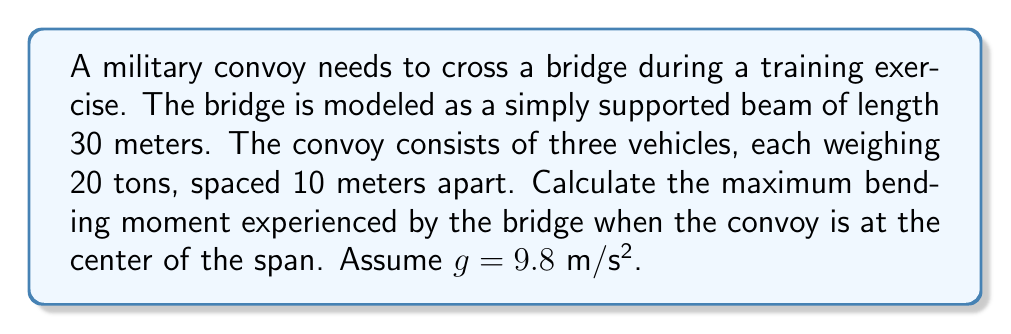Show me your answer to this math problem. Let's approach this step-by-step:

1) First, we need to convert the weight of each vehicle to force:
   $F = mg = 20,000 \text{ kg} \times 9.8 \text{ m/s²} = 196,000 \text{ N} = 196 \text{ kN}$

2) The bridge can be modeled as a simply supported beam with three point loads:

   [asy]
   import geometry;
   
   size(300,100);
   
   draw((0,0)--(300,0),black+1);
   draw((0,-10)--(0,10),black+1);
   draw((300,-10)--(300,10),black+1);
   
   label("30 m", (150,-15), S);
   
   draw((130,0)--(130,50),dashed);
   draw((150,0)--(150,50),dashed);
   draw((170,0)--(170,50),dashed);
   
   draw((130,50)--(170,50),Arrow);
   label("196 kN", (150,60), N);
   
   label("A", (0,-15), S);
   label("B", (300,-15), S);
   [/asy]

3) The maximum bending moment will occur at the center load when the middle vehicle is at the center of the span.

4) To calculate the reaction forces at the supports:
   $\sum F_y = 0: R_A + R_B = 3 \times 196 \text{ kN} = 588 \text{ kN}$
   $\sum M_A = 0: R_B \times 30 - 196 \times 20 - 196 \times 15 - 196 \times 10 = 0$
   $R_B = \frac{196 \times (20 + 15 + 10)}{30} = 294 \text{ kN}$
   $R_A = 588 - 294 = 294 \text{ kN}$

5) The maximum bending moment occurs under the middle load:
   $M_{max} = R_A \times 15 - 196 \times 5$
   $M_{max} = 294 \times 15 - 196 \times 5 = 3430 \text{ kN·m}$

Therefore, the maximum bending moment experienced by the bridge is 3430 kN·m.
Answer: 3430 kN·m 